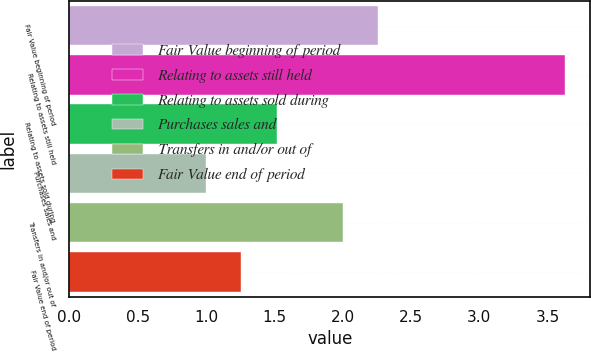Convert chart. <chart><loc_0><loc_0><loc_500><loc_500><bar_chart><fcel>Fair Value beginning of period<fcel>Relating to assets still held<fcel>Relating to assets sold during<fcel>Purchases sales and<fcel>Transfers in and/or out of<fcel>Fair Value end of period<nl><fcel>2.26<fcel>3.63<fcel>1.52<fcel>1<fcel>2<fcel>1.26<nl></chart> 